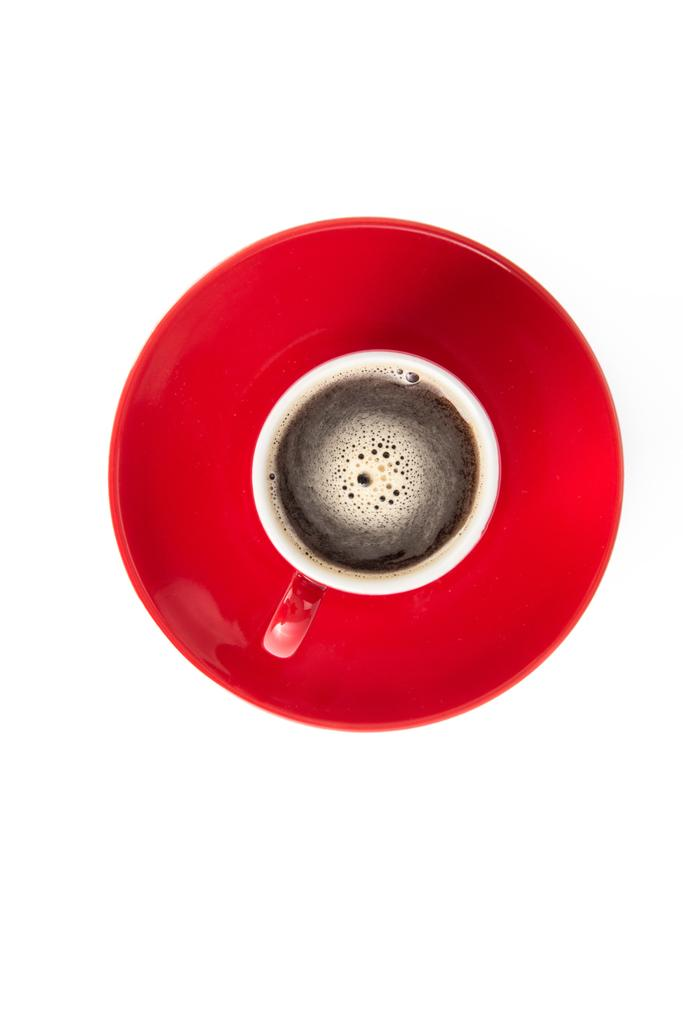What is in the cup that is visible in the image? There is a drink in the cup in the image. How is the cup positioned in the image? The cup is on a plate in the image. What color is the plate? The plate is red. What color is the background of the image? The background of the image is white. How many cats are sitting on the clock in the image? There are no cats or clocks present in the image. 